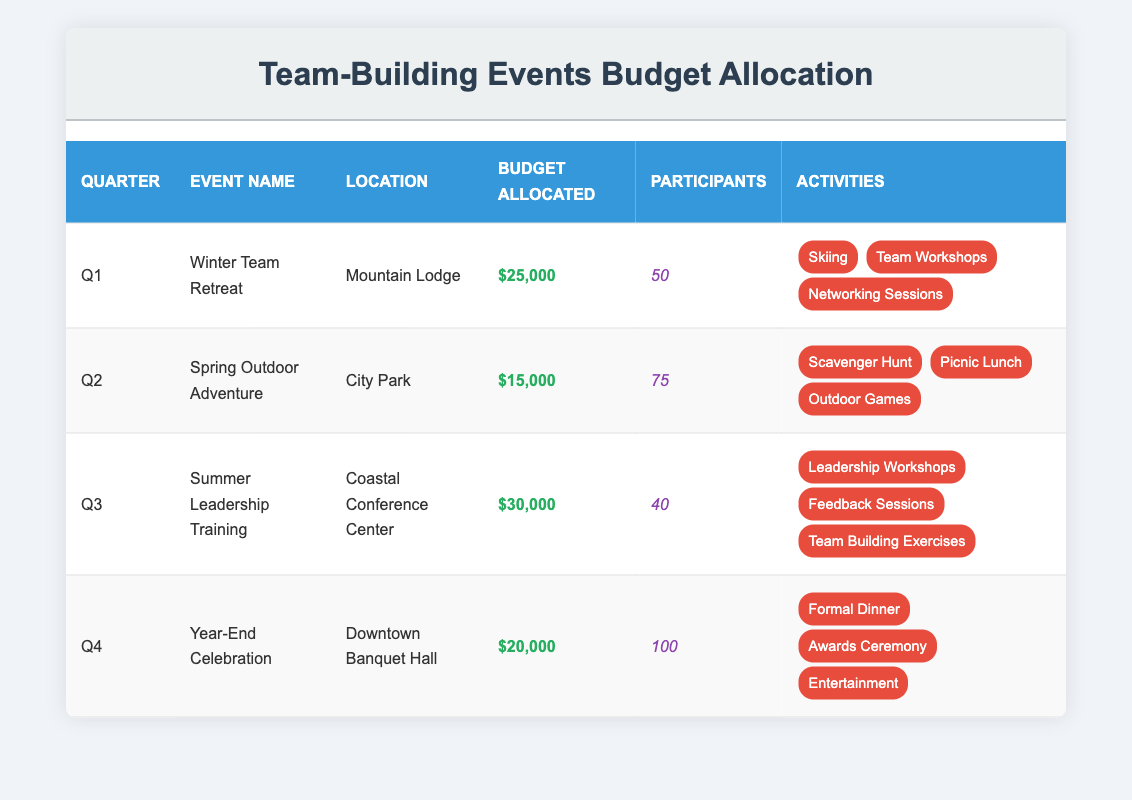What is the budget allocated for the Winter Team Retreat? The table indicates that the budget allocated for the Winter Team Retreat is listed under the "Budget Allocated" column for Q1. It shows $25,000 allocated for this event.
Answer: $25,000 How many participants are expected at the Year-End Celebration? The table shows that under the "Participants" column for Q4, the Year-End Celebration is expected to have 100 participants.
Answer: 100 Which quarter has the highest budget allocation for team-building events? By comparing the "Budget Allocated" values for each quarter, Q3 has the highest allocation of $30,000 for the Summer Leadership Training event.
Answer: Q3 What is the total budget allocated for all team-building events combined? To find the total budget, we add the budget for all four quarters: $25,000 (Q1) + $15,000 (Q2) + $30,000 (Q3) + $20,000 (Q4) = $90,000.
Answer: $90,000 Did any event have more than 75 participants? By examining the "Participants" column, the Year-End Celebration (100 participants) and the Spring Outdoor Adventure (75 participants) meet this criterion. Thus, yes, both Q2 and Q4 had events with more than 75 participants.
Answer: Yes For the Spring Outdoor Adventure, how many activities are planned? The "Activities" column for the Spring Outdoor Adventure lists three activities: Scavenger Hunt, Picnic Lunch, and Outdoor Games. Therefore, there are three activities planned.
Answer: 3 What is the average budget allocated per participant for each event? To find the average budget per participant, we calculate: Q1: $25,000/50 = $500; Q2: $15,000/75 = $200; Q3: $30,000/40 = $750; Q4: $20,000/100 = $200. The average of these values is ($500 + $200 + $750 + $200) / 4 = $412.50.
Answer: $412.50 Is there any event scheduled for Q2? The data clearly shows that there is an event listed in Q2, which is the Spring Outdoor Adventure. Thus, the answer is yes.
Answer: Yes Which event planned for the year has the least number of participants and what is that number? Looking at the "Participants" column, the Summer Leadership Training has the least number of participants, which is 40. This indicates it has the least attendance of the events.
Answer: 40 